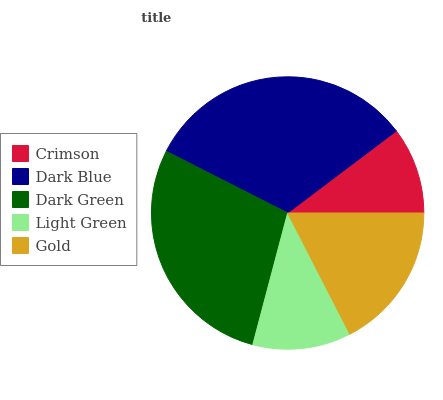Is Crimson the minimum?
Answer yes or no. Yes. Is Dark Blue the maximum?
Answer yes or no. Yes. Is Dark Green the minimum?
Answer yes or no. No. Is Dark Green the maximum?
Answer yes or no. No. Is Dark Blue greater than Dark Green?
Answer yes or no. Yes. Is Dark Green less than Dark Blue?
Answer yes or no. Yes. Is Dark Green greater than Dark Blue?
Answer yes or no. No. Is Dark Blue less than Dark Green?
Answer yes or no. No. Is Gold the high median?
Answer yes or no. Yes. Is Gold the low median?
Answer yes or no. Yes. Is Dark Blue the high median?
Answer yes or no. No. Is Dark Blue the low median?
Answer yes or no. No. 